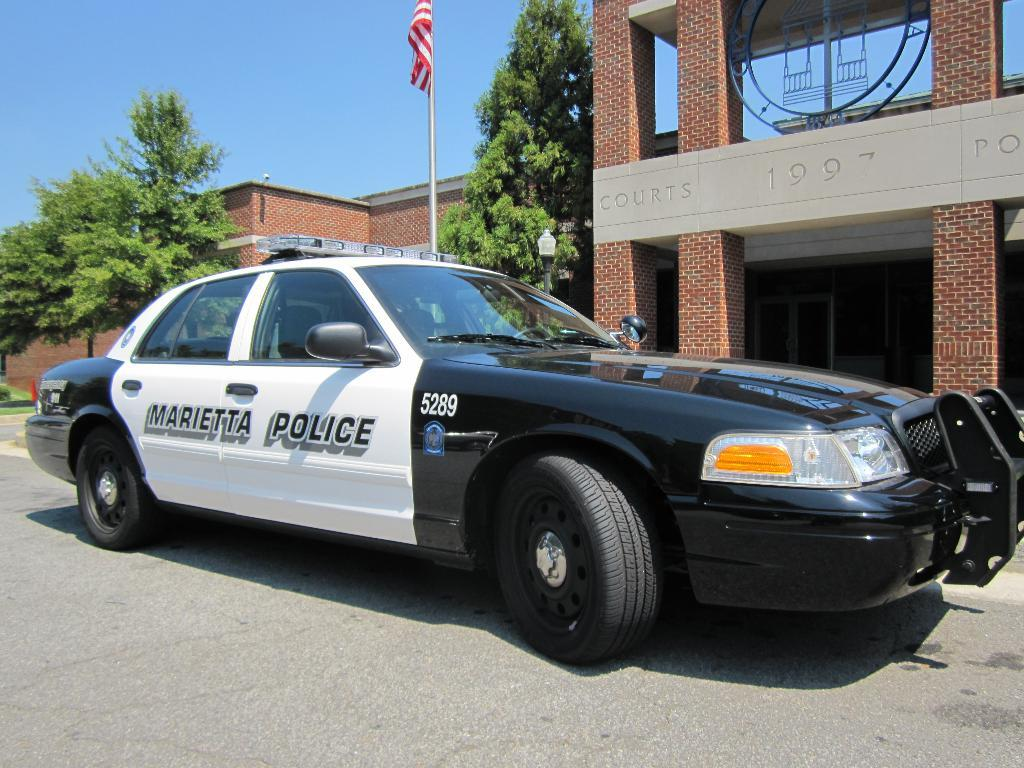<image>
Share a concise interpretation of the image provided. a police car with the name Marietta on it 